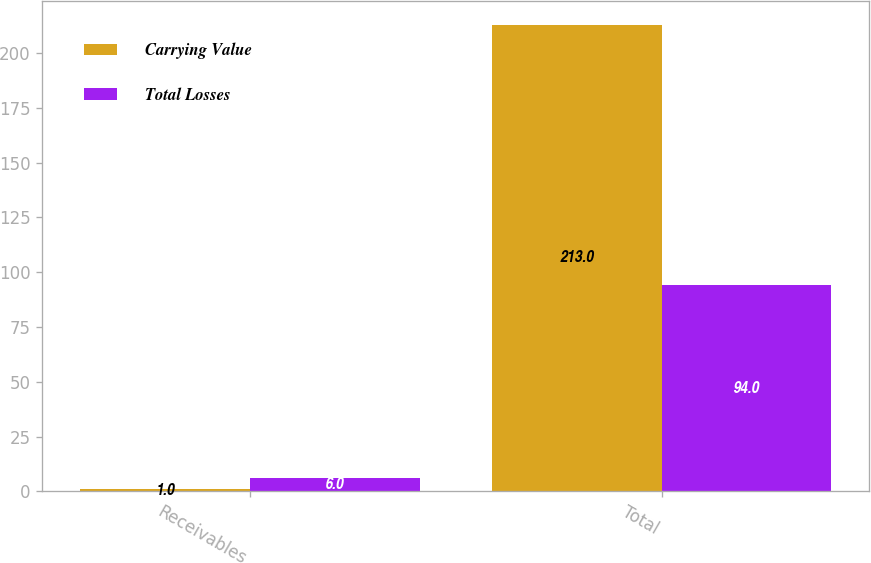<chart> <loc_0><loc_0><loc_500><loc_500><stacked_bar_chart><ecel><fcel>Receivables<fcel>Total<nl><fcel>Carrying Value<fcel>1<fcel>213<nl><fcel>Total Losses<fcel>6<fcel>94<nl></chart> 